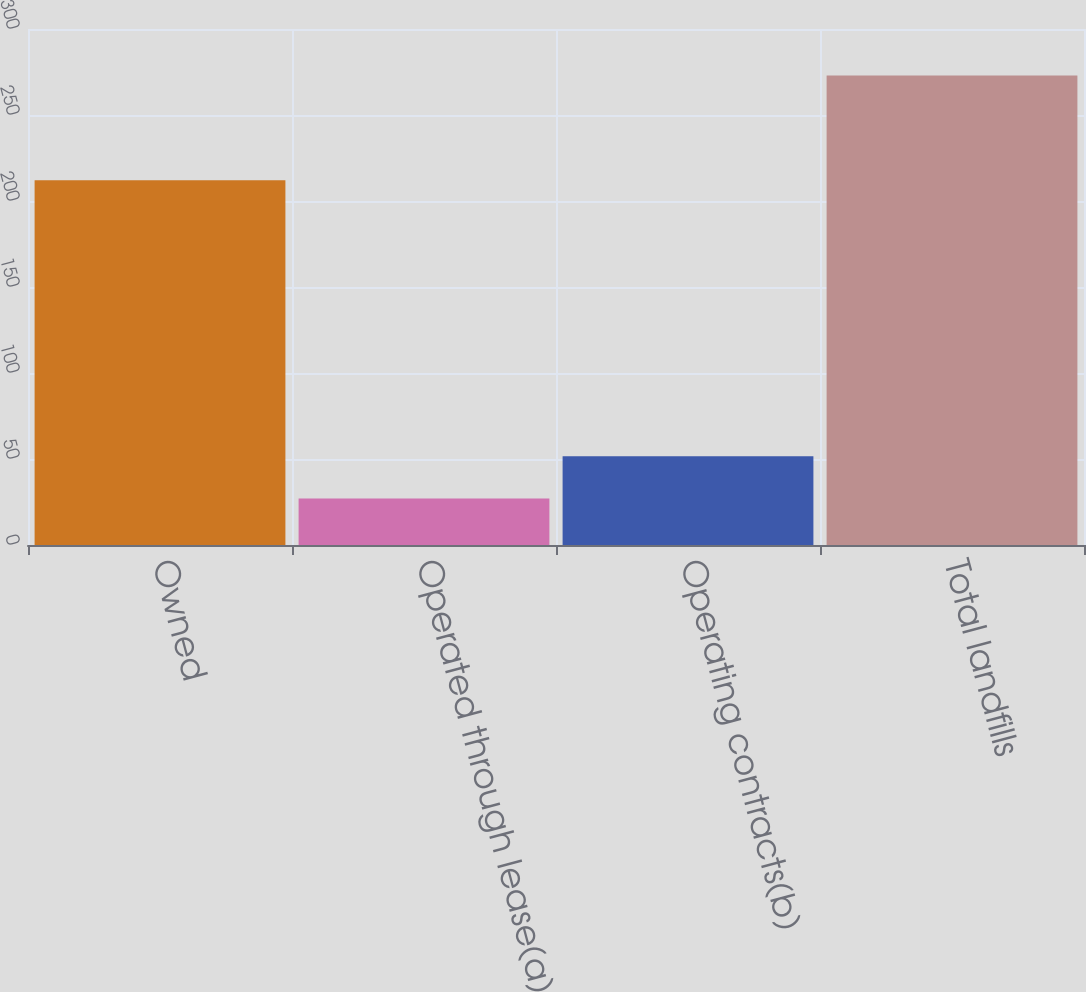<chart> <loc_0><loc_0><loc_500><loc_500><bar_chart><fcel>Owned<fcel>Operated through lease(a)<fcel>Operating contracts(b)<fcel>Total landfills<nl><fcel>212<fcel>27<fcel>51.6<fcel>273<nl></chart> 